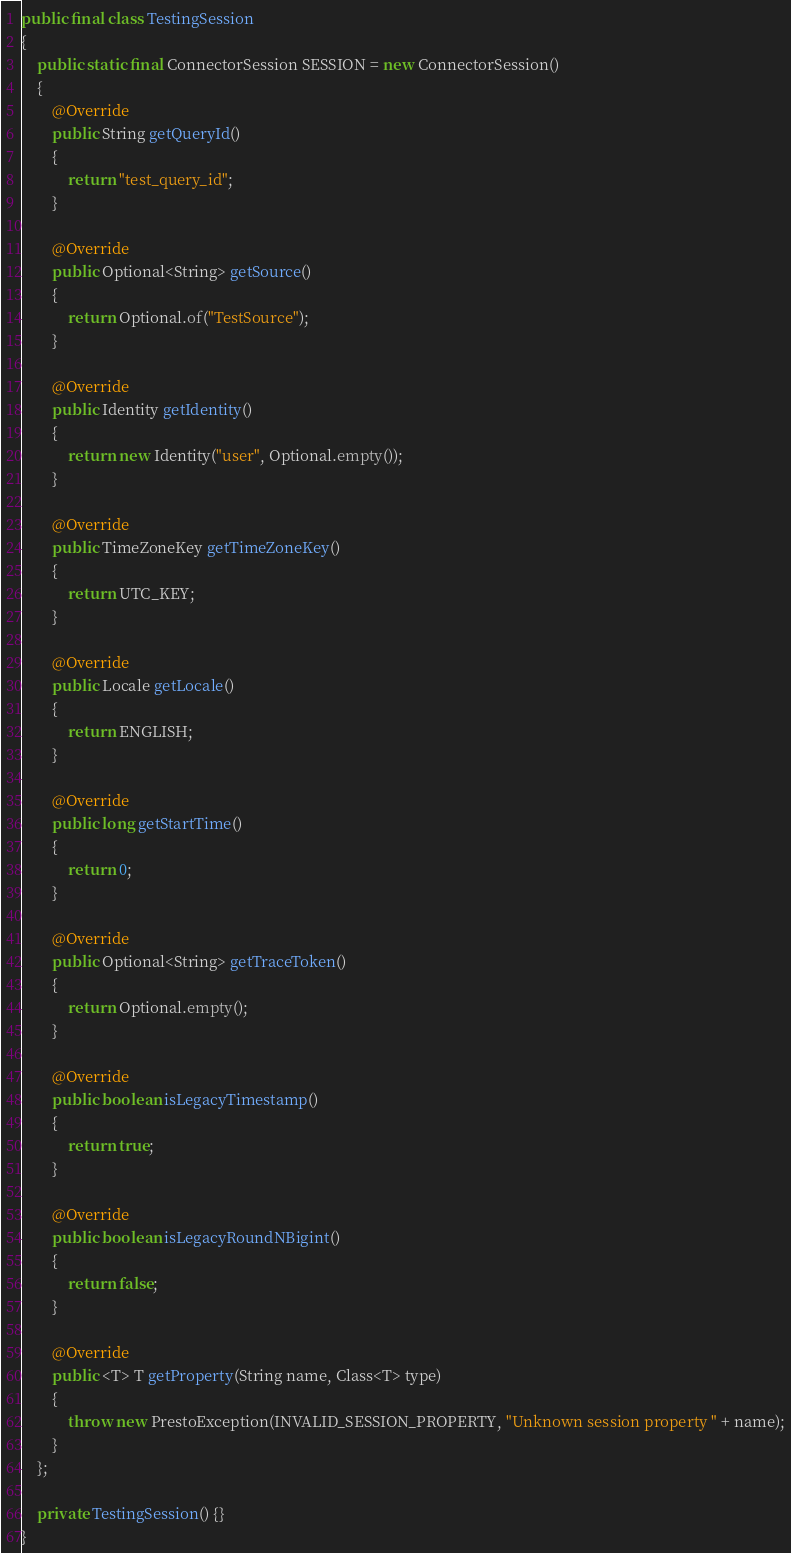Convert code to text. <code><loc_0><loc_0><loc_500><loc_500><_Java_>
public final class TestingSession
{
    public static final ConnectorSession SESSION = new ConnectorSession()
    {
        @Override
        public String getQueryId()
        {
            return "test_query_id";
        }

        @Override
        public Optional<String> getSource()
        {
            return Optional.of("TestSource");
        }

        @Override
        public Identity getIdentity()
        {
            return new Identity("user", Optional.empty());
        }

        @Override
        public TimeZoneKey getTimeZoneKey()
        {
            return UTC_KEY;
        }

        @Override
        public Locale getLocale()
        {
            return ENGLISH;
        }

        @Override
        public long getStartTime()
        {
            return 0;
        }

        @Override
        public Optional<String> getTraceToken()
        {
            return Optional.empty();
        }

        @Override
        public boolean isLegacyTimestamp()
        {
            return true;
        }

        @Override
        public boolean isLegacyRoundNBigint()
        {
            return false;
        }

        @Override
        public <T> T getProperty(String name, Class<T> type)
        {
            throw new PrestoException(INVALID_SESSION_PROPERTY, "Unknown session property " + name);
        }
    };

    private TestingSession() {}
}
</code> 